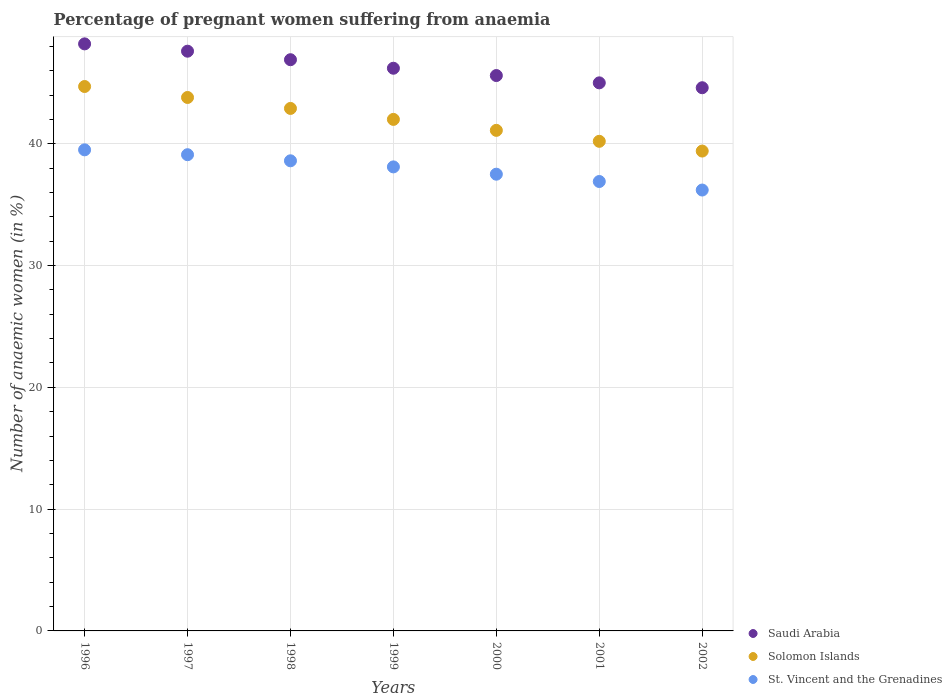How many different coloured dotlines are there?
Keep it short and to the point. 3. Is the number of dotlines equal to the number of legend labels?
Offer a terse response. Yes. What is the number of anaemic women in St. Vincent and the Grenadines in 2002?
Offer a very short reply. 36.2. Across all years, what is the maximum number of anaemic women in St. Vincent and the Grenadines?
Offer a terse response. 39.5. Across all years, what is the minimum number of anaemic women in St. Vincent and the Grenadines?
Your answer should be compact. 36.2. In which year was the number of anaemic women in Saudi Arabia maximum?
Keep it short and to the point. 1996. In which year was the number of anaemic women in Solomon Islands minimum?
Your answer should be compact. 2002. What is the total number of anaemic women in St. Vincent and the Grenadines in the graph?
Make the answer very short. 265.9. What is the difference between the number of anaemic women in Saudi Arabia in 1996 and that in 2002?
Your answer should be compact. 3.6. What is the difference between the number of anaemic women in Solomon Islands in 1997 and the number of anaemic women in Saudi Arabia in 1999?
Give a very brief answer. -2.4. What is the average number of anaemic women in Solomon Islands per year?
Your response must be concise. 42.01. In the year 2000, what is the difference between the number of anaemic women in Solomon Islands and number of anaemic women in St. Vincent and the Grenadines?
Your answer should be very brief. 3.6. What is the ratio of the number of anaemic women in Solomon Islands in 1999 to that in 2002?
Your response must be concise. 1.07. Is the difference between the number of anaemic women in Solomon Islands in 1998 and 2002 greater than the difference between the number of anaemic women in St. Vincent and the Grenadines in 1998 and 2002?
Ensure brevity in your answer.  Yes. What is the difference between the highest and the second highest number of anaemic women in Saudi Arabia?
Your answer should be very brief. 0.6. What is the difference between the highest and the lowest number of anaemic women in St. Vincent and the Grenadines?
Offer a very short reply. 3.3. Is the sum of the number of anaemic women in Saudi Arabia in 1996 and 2001 greater than the maximum number of anaemic women in St. Vincent and the Grenadines across all years?
Provide a short and direct response. Yes. Is the number of anaemic women in Solomon Islands strictly greater than the number of anaemic women in St. Vincent and the Grenadines over the years?
Your answer should be compact. Yes. What is the difference between two consecutive major ticks on the Y-axis?
Provide a short and direct response. 10. Does the graph contain grids?
Your answer should be compact. Yes. Where does the legend appear in the graph?
Keep it short and to the point. Bottom right. How many legend labels are there?
Ensure brevity in your answer.  3. What is the title of the graph?
Provide a short and direct response. Percentage of pregnant women suffering from anaemia. Does "Lesotho" appear as one of the legend labels in the graph?
Provide a succinct answer. No. What is the label or title of the Y-axis?
Your answer should be very brief. Number of anaemic women (in %). What is the Number of anaemic women (in %) of Saudi Arabia in 1996?
Keep it short and to the point. 48.2. What is the Number of anaemic women (in %) in Solomon Islands in 1996?
Make the answer very short. 44.7. What is the Number of anaemic women (in %) in St. Vincent and the Grenadines in 1996?
Offer a very short reply. 39.5. What is the Number of anaemic women (in %) of Saudi Arabia in 1997?
Keep it short and to the point. 47.6. What is the Number of anaemic women (in %) of Solomon Islands in 1997?
Keep it short and to the point. 43.8. What is the Number of anaemic women (in %) of St. Vincent and the Grenadines in 1997?
Keep it short and to the point. 39.1. What is the Number of anaemic women (in %) in Saudi Arabia in 1998?
Give a very brief answer. 46.9. What is the Number of anaemic women (in %) in Solomon Islands in 1998?
Your response must be concise. 42.9. What is the Number of anaemic women (in %) in St. Vincent and the Grenadines in 1998?
Make the answer very short. 38.6. What is the Number of anaemic women (in %) in Saudi Arabia in 1999?
Offer a very short reply. 46.2. What is the Number of anaemic women (in %) in St. Vincent and the Grenadines in 1999?
Your answer should be very brief. 38.1. What is the Number of anaemic women (in %) of Saudi Arabia in 2000?
Your answer should be compact. 45.6. What is the Number of anaemic women (in %) of Solomon Islands in 2000?
Ensure brevity in your answer.  41.1. What is the Number of anaemic women (in %) in St. Vincent and the Grenadines in 2000?
Offer a terse response. 37.5. What is the Number of anaemic women (in %) of Saudi Arabia in 2001?
Your response must be concise. 45. What is the Number of anaemic women (in %) of Solomon Islands in 2001?
Give a very brief answer. 40.2. What is the Number of anaemic women (in %) of St. Vincent and the Grenadines in 2001?
Keep it short and to the point. 36.9. What is the Number of anaemic women (in %) in Saudi Arabia in 2002?
Offer a very short reply. 44.6. What is the Number of anaemic women (in %) in Solomon Islands in 2002?
Your response must be concise. 39.4. What is the Number of anaemic women (in %) of St. Vincent and the Grenadines in 2002?
Provide a succinct answer. 36.2. Across all years, what is the maximum Number of anaemic women (in %) in Saudi Arabia?
Your answer should be very brief. 48.2. Across all years, what is the maximum Number of anaemic women (in %) in Solomon Islands?
Your answer should be compact. 44.7. Across all years, what is the maximum Number of anaemic women (in %) of St. Vincent and the Grenadines?
Ensure brevity in your answer.  39.5. Across all years, what is the minimum Number of anaemic women (in %) of Saudi Arabia?
Give a very brief answer. 44.6. Across all years, what is the minimum Number of anaemic women (in %) in Solomon Islands?
Provide a short and direct response. 39.4. Across all years, what is the minimum Number of anaemic women (in %) in St. Vincent and the Grenadines?
Your response must be concise. 36.2. What is the total Number of anaemic women (in %) of Saudi Arabia in the graph?
Your answer should be compact. 324.1. What is the total Number of anaemic women (in %) of Solomon Islands in the graph?
Make the answer very short. 294.1. What is the total Number of anaemic women (in %) in St. Vincent and the Grenadines in the graph?
Keep it short and to the point. 265.9. What is the difference between the Number of anaemic women (in %) in Saudi Arabia in 1996 and that in 1997?
Provide a short and direct response. 0.6. What is the difference between the Number of anaemic women (in %) in Solomon Islands in 1996 and that in 1997?
Give a very brief answer. 0.9. What is the difference between the Number of anaemic women (in %) in Solomon Islands in 1996 and that in 1998?
Your response must be concise. 1.8. What is the difference between the Number of anaemic women (in %) in St. Vincent and the Grenadines in 1996 and that in 1998?
Provide a short and direct response. 0.9. What is the difference between the Number of anaemic women (in %) of Saudi Arabia in 1996 and that in 1999?
Give a very brief answer. 2. What is the difference between the Number of anaemic women (in %) of Solomon Islands in 1996 and that in 1999?
Provide a succinct answer. 2.7. What is the difference between the Number of anaemic women (in %) of St. Vincent and the Grenadines in 1996 and that in 1999?
Offer a very short reply. 1.4. What is the difference between the Number of anaemic women (in %) of Saudi Arabia in 1996 and that in 2000?
Your response must be concise. 2.6. What is the difference between the Number of anaemic women (in %) of Solomon Islands in 1996 and that in 2000?
Offer a very short reply. 3.6. What is the difference between the Number of anaemic women (in %) of St. Vincent and the Grenadines in 1996 and that in 2000?
Offer a very short reply. 2. What is the difference between the Number of anaemic women (in %) in Saudi Arabia in 1996 and that in 2001?
Make the answer very short. 3.2. What is the difference between the Number of anaemic women (in %) of Solomon Islands in 1996 and that in 2001?
Your answer should be very brief. 4.5. What is the difference between the Number of anaemic women (in %) of St. Vincent and the Grenadines in 1996 and that in 2001?
Your response must be concise. 2.6. What is the difference between the Number of anaemic women (in %) of Saudi Arabia in 1996 and that in 2002?
Give a very brief answer. 3.6. What is the difference between the Number of anaemic women (in %) in Solomon Islands in 1996 and that in 2002?
Keep it short and to the point. 5.3. What is the difference between the Number of anaemic women (in %) of St. Vincent and the Grenadines in 1997 and that in 1998?
Offer a terse response. 0.5. What is the difference between the Number of anaemic women (in %) in Saudi Arabia in 1997 and that in 1999?
Provide a short and direct response. 1.4. What is the difference between the Number of anaemic women (in %) of St. Vincent and the Grenadines in 1997 and that in 1999?
Provide a succinct answer. 1. What is the difference between the Number of anaemic women (in %) in Saudi Arabia in 1997 and that in 2000?
Your response must be concise. 2. What is the difference between the Number of anaemic women (in %) in Solomon Islands in 1997 and that in 2000?
Your answer should be compact. 2.7. What is the difference between the Number of anaemic women (in %) in St. Vincent and the Grenadines in 1997 and that in 2000?
Your answer should be very brief. 1.6. What is the difference between the Number of anaemic women (in %) of Solomon Islands in 1997 and that in 2001?
Provide a succinct answer. 3.6. What is the difference between the Number of anaemic women (in %) in Solomon Islands in 1997 and that in 2002?
Ensure brevity in your answer.  4.4. What is the difference between the Number of anaemic women (in %) of Solomon Islands in 1998 and that in 1999?
Your answer should be very brief. 0.9. What is the difference between the Number of anaemic women (in %) of St. Vincent and the Grenadines in 1998 and that in 1999?
Provide a short and direct response. 0.5. What is the difference between the Number of anaemic women (in %) of Solomon Islands in 1998 and that in 2000?
Give a very brief answer. 1.8. What is the difference between the Number of anaemic women (in %) in St. Vincent and the Grenadines in 1998 and that in 2000?
Offer a very short reply. 1.1. What is the difference between the Number of anaemic women (in %) in St. Vincent and the Grenadines in 1998 and that in 2001?
Keep it short and to the point. 1.7. What is the difference between the Number of anaemic women (in %) in Saudi Arabia in 1999 and that in 2000?
Give a very brief answer. 0.6. What is the difference between the Number of anaemic women (in %) of St. Vincent and the Grenadines in 1999 and that in 2000?
Give a very brief answer. 0.6. What is the difference between the Number of anaemic women (in %) in Solomon Islands in 1999 and that in 2001?
Provide a short and direct response. 1.8. What is the difference between the Number of anaemic women (in %) of St. Vincent and the Grenadines in 1999 and that in 2001?
Offer a very short reply. 1.2. What is the difference between the Number of anaemic women (in %) in Saudi Arabia in 1999 and that in 2002?
Offer a terse response. 1.6. What is the difference between the Number of anaemic women (in %) in Solomon Islands in 1999 and that in 2002?
Offer a terse response. 2.6. What is the difference between the Number of anaemic women (in %) in Solomon Islands in 2000 and that in 2001?
Your response must be concise. 0.9. What is the difference between the Number of anaemic women (in %) of Saudi Arabia in 2000 and that in 2002?
Provide a succinct answer. 1. What is the difference between the Number of anaemic women (in %) in Solomon Islands in 2000 and that in 2002?
Give a very brief answer. 1.7. What is the difference between the Number of anaemic women (in %) in St. Vincent and the Grenadines in 2000 and that in 2002?
Provide a short and direct response. 1.3. What is the difference between the Number of anaemic women (in %) in Saudi Arabia in 1996 and the Number of anaemic women (in %) in Solomon Islands in 1997?
Your answer should be very brief. 4.4. What is the difference between the Number of anaemic women (in %) of Solomon Islands in 1996 and the Number of anaemic women (in %) of St. Vincent and the Grenadines in 1997?
Provide a short and direct response. 5.6. What is the difference between the Number of anaemic women (in %) in Saudi Arabia in 1996 and the Number of anaemic women (in %) in Solomon Islands in 1998?
Keep it short and to the point. 5.3. What is the difference between the Number of anaemic women (in %) in Saudi Arabia in 1996 and the Number of anaemic women (in %) in St. Vincent and the Grenadines in 1998?
Give a very brief answer. 9.6. What is the difference between the Number of anaemic women (in %) of Solomon Islands in 1996 and the Number of anaemic women (in %) of St. Vincent and the Grenadines in 1998?
Offer a very short reply. 6.1. What is the difference between the Number of anaemic women (in %) in Saudi Arabia in 1996 and the Number of anaemic women (in %) in Solomon Islands in 1999?
Your response must be concise. 6.2. What is the difference between the Number of anaemic women (in %) of Solomon Islands in 1996 and the Number of anaemic women (in %) of St. Vincent and the Grenadines in 1999?
Provide a succinct answer. 6.6. What is the difference between the Number of anaemic women (in %) in Solomon Islands in 1996 and the Number of anaemic women (in %) in St. Vincent and the Grenadines in 2001?
Provide a short and direct response. 7.8. What is the difference between the Number of anaemic women (in %) in Saudi Arabia in 1996 and the Number of anaemic women (in %) in Solomon Islands in 2002?
Make the answer very short. 8.8. What is the difference between the Number of anaemic women (in %) in Solomon Islands in 1997 and the Number of anaemic women (in %) in St. Vincent and the Grenadines in 1998?
Give a very brief answer. 5.2. What is the difference between the Number of anaemic women (in %) in Saudi Arabia in 1997 and the Number of anaemic women (in %) in Solomon Islands in 1999?
Keep it short and to the point. 5.6. What is the difference between the Number of anaemic women (in %) in Solomon Islands in 1997 and the Number of anaemic women (in %) in St. Vincent and the Grenadines in 1999?
Offer a very short reply. 5.7. What is the difference between the Number of anaemic women (in %) of Saudi Arabia in 1997 and the Number of anaemic women (in %) of St. Vincent and the Grenadines in 2000?
Provide a short and direct response. 10.1. What is the difference between the Number of anaemic women (in %) of Saudi Arabia in 1997 and the Number of anaemic women (in %) of Solomon Islands in 2001?
Your response must be concise. 7.4. What is the difference between the Number of anaemic women (in %) in Saudi Arabia in 1997 and the Number of anaemic women (in %) in St. Vincent and the Grenadines in 2001?
Your response must be concise. 10.7. What is the difference between the Number of anaemic women (in %) in Solomon Islands in 1997 and the Number of anaemic women (in %) in St. Vincent and the Grenadines in 2001?
Your response must be concise. 6.9. What is the difference between the Number of anaemic women (in %) of Saudi Arabia in 1997 and the Number of anaemic women (in %) of Solomon Islands in 2002?
Ensure brevity in your answer.  8.2. What is the difference between the Number of anaemic women (in %) in Saudi Arabia in 1997 and the Number of anaemic women (in %) in St. Vincent and the Grenadines in 2002?
Your answer should be very brief. 11.4. What is the difference between the Number of anaemic women (in %) in Solomon Islands in 1997 and the Number of anaemic women (in %) in St. Vincent and the Grenadines in 2002?
Offer a very short reply. 7.6. What is the difference between the Number of anaemic women (in %) of Saudi Arabia in 1998 and the Number of anaemic women (in %) of St. Vincent and the Grenadines in 1999?
Your response must be concise. 8.8. What is the difference between the Number of anaemic women (in %) in Solomon Islands in 1998 and the Number of anaemic women (in %) in St. Vincent and the Grenadines in 1999?
Your answer should be compact. 4.8. What is the difference between the Number of anaemic women (in %) in Saudi Arabia in 1998 and the Number of anaemic women (in %) in Solomon Islands in 2000?
Your answer should be very brief. 5.8. What is the difference between the Number of anaemic women (in %) of Saudi Arabia in 1998 and the Number of anaemic women (in %) of St. Vincent and the Grenadines in 2000?
Keep it short and to the point. 9.4. What is the difference between the Number of anaemic women (in %) in Solomon Islands in 1998 and the Number of anaemic women (in %) in St. Vincent and the Grenadines in 2000?
Offer a terse response. 5.4. What is the difference between the Number of anaemic women (in %) in Saudi Arabia in 1998 and the Number of anaemic women (in %) in St. Vincent and the Grenadines in 2001?
Your response must be concise. 10. What is the difference between the Number of anaemic women (in %) of Solomon Islands in 1998 and the Number of anaemic women (in %) of St. Vincent and the Grenadines in 2001?
Your answer should be compact. 6. What is the difference between the Number of anaemic women (in %) in Saudi Arabia in 1998 and the Number of anaemic women (in %) in Solomon Islands in 2002?
Your response must be concise. 7.5. What is the difference between the Number of anaemic women (in %) of Saudi Arabia in 1999 and the Number of anaemic women (in %) of Solomon Islands in 2000?
Offer a terse response. 5.1. What is the difference between the Number of anaemic women (in %) in Saudi Arabia in 1999 and the Number of anaemic women (in %) in St. Vincent and the Grenadines in 2000?
Your answer should be compact. 8.7. What is the difference between the Number of anaemic women (in %) of Solomon Islands in 1999 and the Number of anaemic women (in %) of St. Vincent and the Grenadines in 2000?
Make the answer very short. 4.5. What is the difference between the Number of anaemic women (in %) of Saudi Arabia in 1999 and the Number of anaemic women (in %) of Solomon Islands in 2001?
Your answer should be compact. 6. What is the difference between the Number of anaemic women (in %) of Saudi Arabia in 1999 and the Number of anaemic women (in %) of St. Vincent and the Grenadines in 2001?
Provide a short and direct response. 9.3. What is the difference between the Number of anaemic women (in %) of Saudi Arabia in 1999 and the Number of anaemic women (in %) of Solomon Islands in 2002?
Keep it short and to the point. 6.8. What is the difference between the Number of anaemic women (in %) in Saudi Arabia in 1999 and the Number of anaemic women (in %) in St. Vincent and the Grenadines in 2002?
Offer a terse response. 10. What is the difference between the Number of anaemic women (in %) of Solomon Islands in 1999 and the Number of anaemic women (in %) of St. Vincent and the Grenadines in 2002?
Keep it short and to the point. 5.8. What is the difference between the Number of anaemic women (in %) in Saudi Arabia in 2000 and the Number of anaemic women (in %) in St. Vincent and the Grenadines in 2001?
Provide a succinct answer. 8.7. What is the difference between the Number of anaemic women (in %) in Solomon Islands in 2000 and the Number of anaemic women (in %) in St. Vincent and the Grenadines in 2001?
Offer a very short reply. 4.2. What is the difference between the Number of anaemic women (in %) of Solomon Islands in 2000 and the Number of anaemic women (in %) of St. Vincent and the Grenadines in 2002?
Offer a terse response. 4.9. What is the difference between the Number of anaemic women (in %) of Saudi Arabia in 2001 and the Number of anaemic women (in %) of St. Vincent and the Grenadines in 2002?
Offer a very short reply. 8.8. What is the average Number of anaemic women (in %) in Saudi Arabia per year?
Give a very brief answer. 46.3. What is the average Number of anaemic women (in %) of Solomon Islands per year?
Offer a very short reply. 42.01. What is the average Number of anaemic women (in %) of St. Vincent and the Grenadines per year?
Your response must be concise. 37.99. In the year 1997, what is the difference between the Number of anaemic women (in %) in Saudi Arabia and Number of anaemic women (in %) in Solomon Islands?
Provide a succinct answer. 3.8. In the year 1997, what is the difference between the Number of anaemic women (in %) of Saudi Arabia and Number of anaemic women (in %) of St. Vincent and the Grenadines?
Provide a short and direct response. 8.5. In the year 1997, what is the difference between the Number of anaemic women (in %) in Solomon Islands and Number of anaemic women (in %) in St. Vincent and the Grenadines?
Your answer should be very brief. 4.7. In the year 1998, what is the difference between the Number of anaemic women (in %) in Saudi Arabia and Number of anaemic women (in %) in St. Vincent and the Grenadines?
Your response must be concise. 8.3. In the year 1998, what is the difference between the Number of anaemic women (in %) in Solomon Islands and Number of anaemic women (in %) in St. Vincent and the Grenadines?
Your response must be concise. 4.3. In the year 1999, what is the difference between the Number of anaemic women (in %) of Saudi Arabia and Number of anaemic women (in %) of Solomon Islands?
Your answer should be very brief. 4.2. In the year 2000, what is the difference between the Number of anaemic women (in %) in Saudi Arabia and Number of anaemic women (in %) in St. Vincent and the Grenadines?
Your answer should be compact. 8.1. In the year 2000, what is the difference between the Number of anaemic women (in %) in Solomon Islands and Number of anaemic women (in %) in St. Vincent and the Grenadines?
Your answer should be very brief. 3.6. In the year 2001, what is the difference between the Number of anaemic women (in %) of Saudi Arabia and Number of anaemic women (in %) of Solomon Islands?
Make the answer very short. 4.8. In the year 2001, what is the difference between the Number of anaemic women (in %) of Saudi Arabia and Number of anaemic women (in %) of St. Vincent and the Grenadines?
Offer a very short reply. 8.1. In the year 2001, what is the difference between the Number of anaemic women (in %) in Solomon Islands and Number of anaemic women (in %) in St. Vincent and the Grenadines?
Your answer should be compact. 3.3. In the year 2002, what is the difference between the Number of anaemic women (in %) in Saudi Arabia and Number of anaemic women (in %) in Solomon Islands?
Your answer should be compact. 5.2. In the year 2002, what is the difference between the Number of anaemic women (in %) of Solomon Islands and Number of anaemic women (in %) of St. Vincent and the Grenadines?
Provide a short and direct response. 3.2. What is the ratio of the Number of anaemic women (in %) of Saudi Arabia in 1996 to that in 1997?
Offer a terse response. 1.01. What is the ratio of the Number of anaemic women (in %) of Solomon Islands in 1996 to that in 1997?
Offer a very short reply. 1.02. What is the ratio of the Number of anaemic women (in %) in St. Vincent and the Grenadines in 1996 to that in 1997?
Provide a short and direct response. 1.01. What is the ratio of the Number of anaemic women (in %) in Saudi Arabia in 1996 to that in 1998?
Your answer should be compact. 1.03. What is the ratio of the Number of anaemic women (in %) in Solomon Islands in 1996 to that in 1998?
Provide a succinct answer. 1.04. What is the ratio of the Number of anaemic women (in %) in St. Vincent and the Grenadines in 1996 to that in 1998?
Keep it short and to the point. 1.02. What is the ratio of the Number of anaemic women (in %) of Saudi Arabia in 1996 to that in 1999?
Give a very brief answer. 1.04. What is the ratio of the Number of anaemic women (in %) in Solomon Islands in 1996 to that in 1999?
Your response must be concise. 1.06. What is the ratio of the Number of anaemic women (in %) in St. Vincent and the Grenadines in 1996 to that in 1999?
Offer a very short reply. 1.04. What is the ratio of the Number of anaemic women (in %) of Saudi Arabia in 1996 to that in 2000?
Your answer should be very brief. 1.06. What is the ratio of the Number of anaemic women (in %) of Solomon Islands in 1996 to that in 2000?
Keep it short and to the point. 1.09. What is the ratio of the Number of anaemic women (in %) in St. Vincent and the Grenadines in 1996 to that in 2000?
Keep it short and to the point. 1.05. What is the ratio of the Number of anaemic women (in %) in Saudi Arabia in 1996 to that in 2001?
Ensure brevity in your answer.  1.07. What is the ratio of the Number of anaemic women (in %) in Solomon Islands in 1996 to that in 2001?
Make the answer very short. 1.11. What is the ratio of the Number of anaemic women (in %) of St. Vincent and the Grenadines in 1996 to that in 2001?
Your response must be concise. 1.07. What is the ratio of the Number of anaemic women (in %) of Saudi Arabia in 1996 to that in 2002?
Offer a very short reply. 1.08. What is the ratio of the Number of anaemic women (in %) of Solomon Islands in 1996 to that in 2002?
Your answer should be very brief. 1.13. What is the ratio of the Number of anaemic women (in %) in St. Vincent and the Grenadines in 1996 to that in 2002?
Ensure brevity in your answer.  1.09. What is the ratio of the Number of anaemic women (in %) in Saudi Arabia in 1997 to that in 1998?
Your answer should be very brief. 1.01. What is the ratio of the Number of anaemic women (in %) of Solomon Islands in 1997 to that in 1998?
Your answer should be compact. 1.02. What is the ratio of the Number of anaemic women (in %) in Saudi Arabia in 1997 to that in 1999?
Your answer should be compact. 1.03. What is the ratio of the Number of anaemic women (in %) in Solomon Islands in 1997 to that in 1999?
Your answer should be compact. 1.04. What is the ratio of the Number of anaemic women (in %) in St. Vincent and the Grenadines in 1997 to that in 1999?
Your answer should be very brief. 1.03. What is the ratio of the Number of anaemic women (in %) in Saudi Arabia in 1997 to that in 2000?
Your response must be concise. 1.04. What is the ratio of the Number of anaemic women (in %) in Solomon Islands in 1997 to that in 2000?
Ensure brevity in your answer.  1.07. What is the ratio of the Number of anaemic women (in %) in St. Vincent and the Grenadines in 1997 to that in 2000?
Make the answer very short. 1.04. What is the ratio of the Number of anaemic women (in %) in Saudi Arabia in 1997 to that in 2001?
Offer a terse response. 1.06. What is the ratio of the Number of anaemic women (in %) of Solomon Islands in 1997 to that in 2001?
Your response must be concise. 1.09. What is the ratio of the Number of anaemic women (in %) in St. Vincent and the Grenadines in 1997 to that in 2001?
Provide a short and direct response. 1.06. What is the ratio of the Number of anaemic women (in %) in Saudi Arabia in 1997 to that in 2002?
Your response must be concise. 1.07. What is the ratio of the Number of anaemic women (in %) of Solomon Islands in 1997 to that in 2002?
Offer a terse response. 1.11. What is the ratio of the Number of anaemic women (in %) of St. Vincent and the Grenadines in 1997 to that in 2002?
Provide a short and direct response. 1.08. What is the ratio of the Number of anaemic women (in %) in Saudi Arabia in 1998 to that in 1999?
Your answer should be very brief. 1.02. What is the ratio of the Number of anaemic women (in %) in Solomon Islands in 1998 to that in 1999?
Your answer should be very brief. 1.02. What is the ratio of the Number of anaemic women (in %) of St. Vincent and the Grenadines in 1998 to that in 1999?
Your answer should be compact. 1.01. What is the ratio of the Number of anaemic women (in %) of Saudi Arabia in 1998 to that in 2000?
Give a very brief answer. 1.03. What is the ratio of the Number of anaemic women (in %) in Solomon Islands in 1998 to that in 2000?
Ensure brevity in your answer.  1.04. What is the ratio of the Number of anaemic women (in %) in St. Vincent and the Grenadines in 1998 to that in 2000?
Ensure brevity in your answer.  1.03. What is the ratio of the Number of anaemic women (in %) of Saudi Arabia in 1998 to that in 2001?
Offer a terse response. 1.04. What is the ratio of the Number of anaemic women (in %) of Solomon Islands in 1998 to that in 2001?
Provide a succinct answer. 1.07. What is the ratio of the Number of anaemic women (in %) in St. Vincent and the Grenadines in 1998 to that in 2001?
Provide a succinct answer. 1.05. What is the ratio of the Number of anaemic women (in %) in Saudi Arabia in 1998 to that in 2002?
Give a very brief answer. 1.05. What is the ratio of the Number of anaemic women (in %) in Solomon Islands in 1998 to that in 2002?
Offer a terse response. 1.09. What is the ratio of the Number of anaemic women (in %) in St. Vincent and the Grenadines in 1998 to that in 2002?
Provide a succinct answer. 1.07. What is the ratio of the Number of anaemic women (in %) in Saudi Arabia in 1999 to that in 2000?
Provide a succinct answer. 1.01. What is the ratio of the Number of anaemic women (in %) in Solomon Islands in 1999 to that in 2000?
Make the answer very short. 1.02. What is the ratio of the Number of anaemic women (in %) of Saudi Arabia in 1999 to that in 2001?
Provide a succinct answer. 1.03. What is the ratio of the Number of anaemic women (in %) in Solomon Islands in 1999 to that in 2001?
Offer a terse response. 1.04. What is the ratio of the Number of anaemic women (in %) of St. Vincent and the Grenadines in 1999 to that in 2001?
Your answer should be compact. 1.03. What is the ratio of the Number of anaemic women (in %) in Saudi Arabia in 1999 to that in 2002?
Give a very brief answer. 1.04. What is the ratio of the Number of anaemic women (in %) in Solomon Islands in 1999 to that in 2002?
Offer a terse response. 1.07. What is the ratio of the Number of anaemic women (in %) in St. Vincent and the Grenadines in 1999 to that in 2002?
Give a very brief answer. 1.05. What is the ratio of the Number of anaemic women (in %) in Saudi Arabia in 2000 to that in 2001?
Provide a short and direct response. 1.01. What is the ratio of the Number of anaemic women (in %) of Solomon Islands in 2000 to that in 2001?
Ensure brevity in your answer.  1.02. What is the ratio of the Number of anaemic women (in %) in St. Vincent and the Grenadines in 2000 to that in 2001?
Provide a succinct answer. 1.02. What is the ratio of the Number of anaemic women (in %) of Saudi Arabia in 2000 to that in 2002?
Provide a succinct answer. 1.02. What is the ratio of the Number of anaemic women (in %) of Solomon Islands in 2000 to that in 2002?
Make the answer very short. 1.04. What is the ratio of the Number of anaemic women (in %) in St. Vincent and the Grenadines in 2000 to that in 2002?
Offer a very short reply. 1.04. What is the ratio of the Number of anaemic women (in %) of Solomon Islands in 2001 to that in 2002?
Your response must be concise. 1.02. What is the ratio of the Number of anaemic women (in %) of St. Vincent and the Grenadines in 2001 to that in 2002?
Offer a very short reply. 1.02. What is the difference between the highest and the second highest Number of anaemic women (in %) of Saudi Arabia?
Offer a terse response. 0.6. What is the difference between the highest and the lowest Number of anaemic women (in %) of Saudi Arabia?
Offer a very short reply. 3.6. What is the difference between the highest and the lowest Number of anaemic women (in %) of St. Vincent and the Grenadines?
Your answer should be very brief. 3.3. 